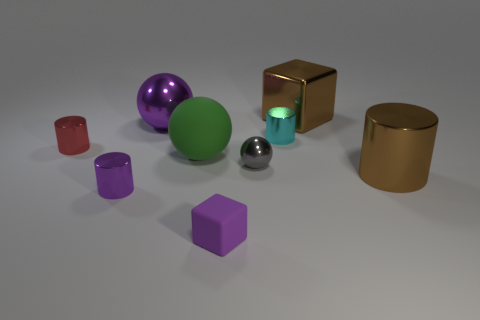Subtract all blocks. How many objects are left? 7 Add 7 small red shiny cylinders. How many small red shiny cylinders exist? 8 Subtract 0 brown balls. How many objects are left? 9 Subtract all small red shiny cylinders. Subtract all red cylinders. How many objects are left? 7 Add 8 shiny balls. How many shiny balls are left? 10 